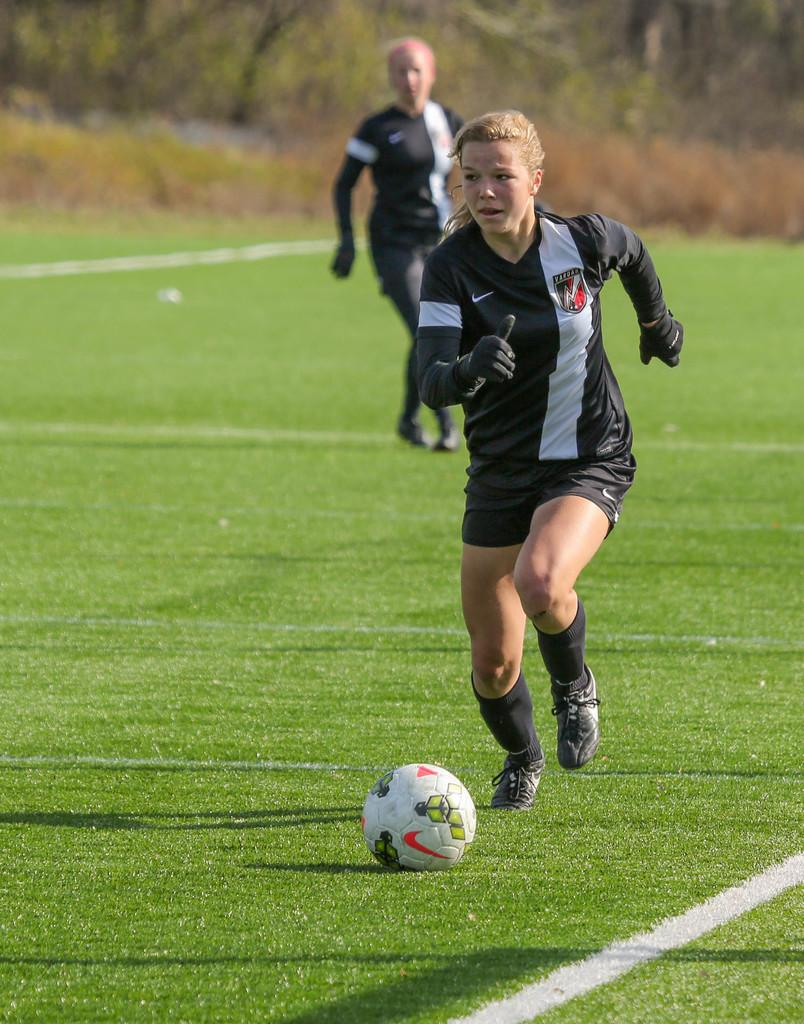How many people are playing football in the image? There are two people in the image playing football. What is the setting of the football game? The football game is taking place on a ground. Can you describe the background of the image? The background of the image is blurred. What type of wood is being used to make the banana rice in the image? There is no banana rice or wood present in the image; it features two people playing football on a ground. 